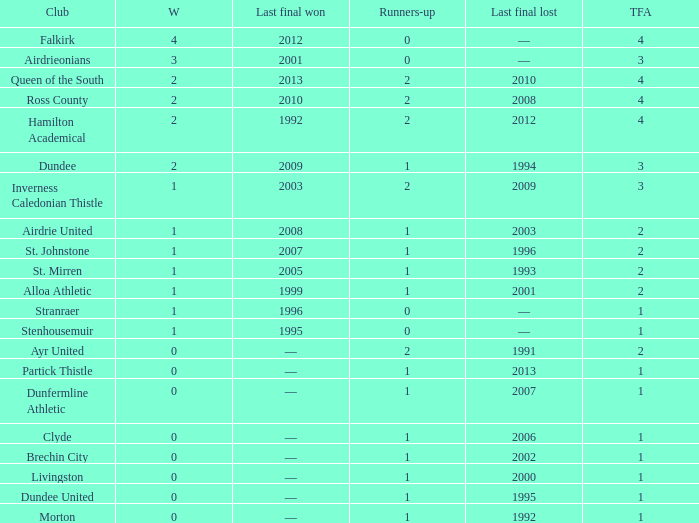How manywins for dunfermline athletic that has a total final appearances less than 2? 0.0. 